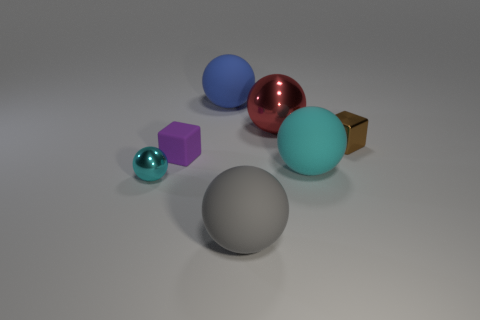Is there a small metal block that has the same color as the big metal sphere?
Your answer should be very brief. No. Is there a brown metal thing of the same shape as the gray thing?
Offer a very short reply. No. There is a object that is right of the red ball and in front of the small shiny cube; what is its shape?
Provide a succinct answer. Sphere. What number of other tiny brown cubes have the same material as the brown block?
Your response must be concise. 0. Is the number of large shiny spheres that are in front of the small purple matte cube less than the number of cyan objects?
Your answer should be very brief. Yes. Are there any gray matte things in front of the large sphere in front of the big cyan rubber object?
Give a very brief answer. No. Is there any other thing that has the same shape as the tiny brown object?
Your response must be concise. Yes. Is the cyan metal thing the same size as the gray rubber thing?
Make the answer very short. No. There is a tiny block that is on the left side of the tiny cube right of the big rubber object in front of the cyan matte sphere; what is it made of?
Your response must be concise. Rubber. Are there the same number of blue rubber things in front of the small purple rubber object and big purple metal blocks?
Offer a very short reply. Yes. 